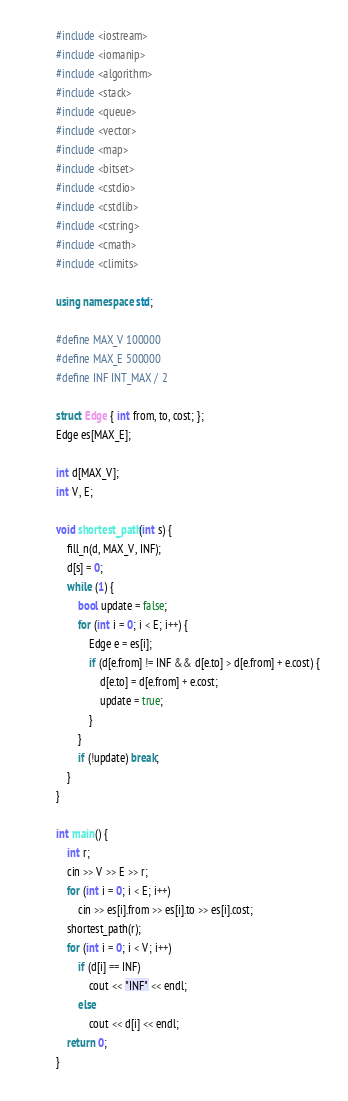Convert code to text. <code><loc_0><loc_0><loc_500><loc_500><_C++_>#include <iostream>
#include <iomanip>
#include <algorithm>
#include <stack>
#include <queue>
#include <vector>
#include <map>
#include <bitset>
#include <cstdio>
#include <cstdlib>
#include <cstring>
#include <cmath>
#include <climits>

using namespace std;

#define MAX_V 100000
#define MAX_E 500000
#define INF INT_MAX / 2

struct Edge { int from, to, cost; };
Edge es[MAX_E];

int d[MAX_V];
int V, E;

void shortest_path(int s) {
	fill_n(d, MAX_V, INF);
	d[s] = 0;
	while (1) {
		bool update = false;
		for (int i = 0; i < E; i++) {
			Edge e = es[i];
			if (d[e.from] != INF && d[e.to] > d[e.from] + e.cost) {
				d[e.to] = d[e.from] + e.cost;
				update = true;
			}
		}
		if (!update) break;
	}
}

int main() {
	int r;
	cin >> V >> E >> r;
	for (int i = 0; i < E; i++)
		cin >> es[i].from >> es[i].to >> es[i].cost;
	shortest_path(r);
	for (int i = 0; i < V; i++)
		if (d[i] == INF)
			cout << "INF" << endl;
		else
			cout << d[i] << endl;
	return 0;
}</code> 